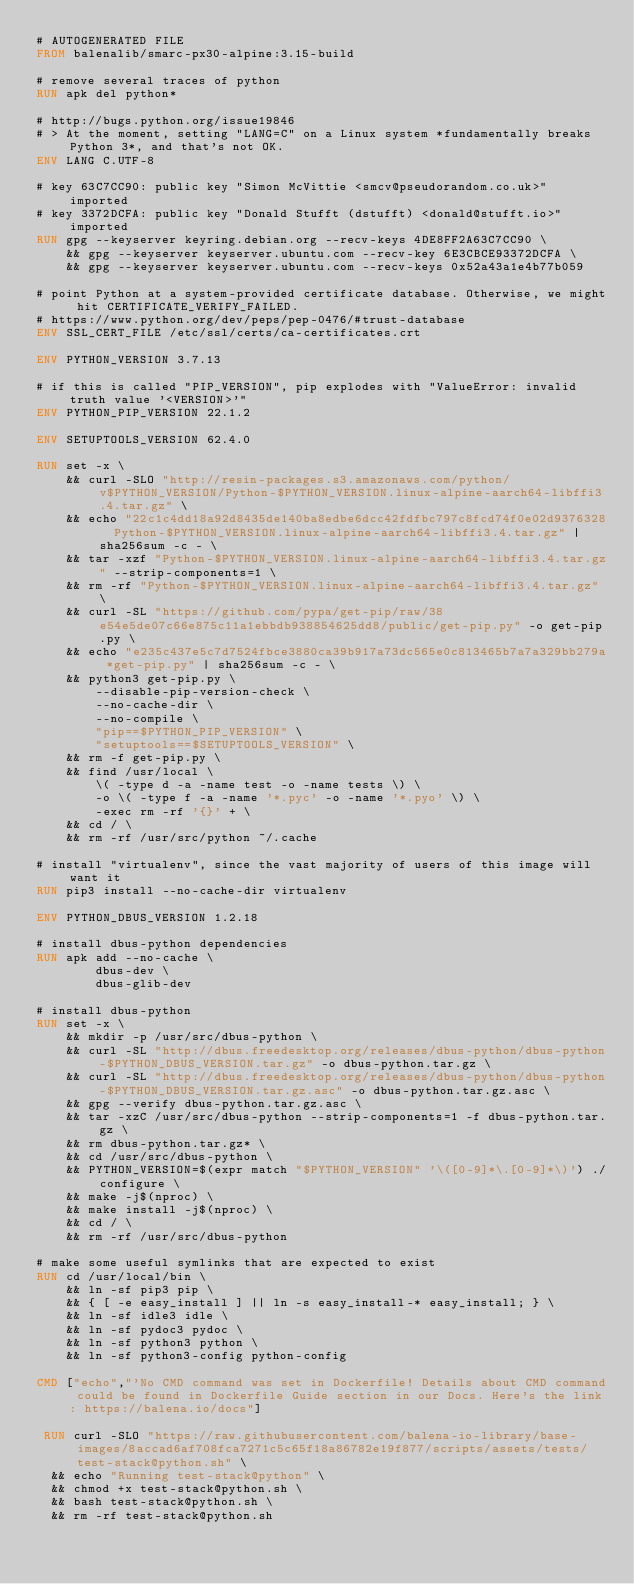Convert code to text. <code><loc_0><loc_0><loc_500><loc_500><_Dockerfile_># AUTOGENERATED FILE
FROM balenalib/smarc-px30-alpine:3.15-build

# remove several traces of python
RUN apk del python*

# http://bugs.python.org/issue19846
# > At the moment, setting "LANG=C" on a Linux system *fundamentally breaks Python 3*, and that's not OK.
ENV LANG C.UTF-8

# key 63C7CC90: public key "Simon McVittie <smcv@pseudorandom.co.uk>" imported
# key 3372DCFA: public key "Donald Stufft (dstufft) <donald@stufft.io>" imported
RUN gpg --keyserver keyring.debian.org --recv-keys 4DE8FF2A63C7CC90 \
	&& gpg --keyserver keyserver.ubuntu.com --recv-key 6E3CBCE93372DCFA \
	&& gpg --keyserver keyserver.ubuntu.com --recv-keys 0x52a43a1e4b77b059

# point Python at a system-provided certificate database. Otherwise, we might hit CERTIFICATE_VERIFY_FAILED.
# https://www.python.org/dev/peps/pep-0476/#trust-database
ENV SSL_CERT_FILE /etc/ssl/certs/ca-certificates.crt

ENV PYTHON_VERSION 3.7.13

# if this is called "PIP_VERSION", pip explodes with "ValueError: invalid truth value '<VERSION>'"
ENV PYTHON_PIP_VERSION 22.1.2

ENV SETUPTOOLS_VERSION 62.4.0

RUN set -x \
	&& curl -SLO "http://resin-packages.s3.amazonaws.com/python/v$PYTHON_VERSION/Python-$PYTHON_VERSION.linux-alpine-aarch64-libffi3.4.tar.gz" \
	&& echo "22c1c4dd18a92d8435de140ba8edbe6dcc42fdfbc797c8fcd74f0e02d9376328  Python-$PYTHON_VERSION.linux-alpine-aarch64-libffi3.4.tar.gz" | sha256sum -c - \
	&& tar -xzf "Python-$PYTHON_VERSION.linux-alpine-aarch64-libffi3.4.tar.gz" --strip-components=1 \
	&& rm -rf "Python-$PYTHON_VERSION.linux-alpine-aarch64-libffi3.4.tar.gz" \
	&& curl -SL "https://github.com/pypa/get-pip/raw/38e54e5de07c66e875c11a1ebbdb938854625dd8/public/get-pip.py" -o get-pip.py \
    && echo "e235c437e5c7d7524fbce3880ca39b917a73dc565e0c813465b7a7a329bb279a *get-pip.py" | sha256sum -c - \
    && python3 get-pip.py \
        --disable-pip-version-check \
        --no-cache-dir \
        --no-compile \
        "pip==$PYTHON_PIP_VERSION" \
        "setuptools==$SETUPTOOLS_VERSION" \
	&& rm -f get-pip.py \
	&& find /usr/local \
		\( -type d -a -name test -o -name tests \) \
		-o \( -type f -a -name '*.pyc' -o -name '*.pyo' \) \
		-exec rm -rf '{}' + \
	&& cd / \
	&& rm -rf /usr/src/python ~/.cache

# install "virtualenv", since the vast majority of users of this image will want it
RUN pip3 install --no-cache-dir virtualenv

ENV PYTHON_DBUS_VERSION 1.2.18

# install dbus-python dependencies 
RUN apk add --no-cache \
		dbus-dev \
		dbus-glib-dev

# install dbus-python
RUN set -x \
	&& mkdir -p /usr/src/dbus-python \
	&& curl -SL "http://dbus.freedesktop.org/releases/dbus-python/dbus-python-$PYTHON_DBUS_VERSION.tar.gz" -o dbus-python.tar.gz \
	&& curl -SL "http://dbus.freedesktop.org/releases/dbus-python/dbus-python-$PYTHON_DBUS_VERSION.tar.gz.asc" -o dbus-python.tar.gz.asc \
	&& gpg --verify dbus-python.tar.gz.asc \
	&& tar -xzC /usr/src/dbus-python --strip-components=1 -f dbus-python.tar.gz \
	&& rm dbus-python.tar.gz* \
	&& cd /usr/src/dbus-python \
	&& PYTHON_VERSION=$(expr match "$PYTHON_VERSION" '\([0-9]*\.[0-9]*\)') ./configure \
	&& make -j$(nproc) \
	&& make install -j$(nproc) \
	&& cd / \
	&& rm -rf /usr/src/dbus-python

# make some useful symlinks that are expected to exist
RUN cd /usr/local/bin \
	&& ln -sf pip3 pip \
	&& { [ -e easy_install ] || ln -s easy_install-* easy_install; } \
	&& ln -sf idle3 idle \
	&& ln -sf pydoc3 pydoc \
	&& ln -sf python3 python \
	&& ln -sf python3-config python-config

CMD ["echo","'No CMD command was set in Dockerfile! Details about CMD command could be found in Dockerfile Guide section in our Docs. Here's the link: https://balena.io/docs"]

 RUN curl -SLO "https://raw.githubusercontent.com/balena-io-library/base-images/8accad6af708fca7271c5c65f18a86782e19f877/scripts/assets/tests/test-stack@python.sh" \
  && echo "Running test-stack@python" \
  && chmod +x test-stack@python.sh \
  && bash test-stack@python.sh \
  && rm -rf test-stack@python.sh 
</code> 